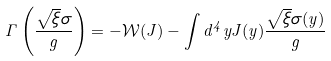<formula> <loc_0><loc_0><loc_500><loc_500>\Gamma \left ( \frac { \sqrt { \xi } \sigma } { g } \right ) = - \mathcal { W } ( J ) - \int d ^ { 4 } y J ( y ) \frac { \sqrt { \xi } \sigma ( y ) } { g }</formula> 